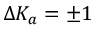<formula> <loc_0><loc_0><loc_500><loc_500>\Delta K _ { a } = \pm 1</formula> 